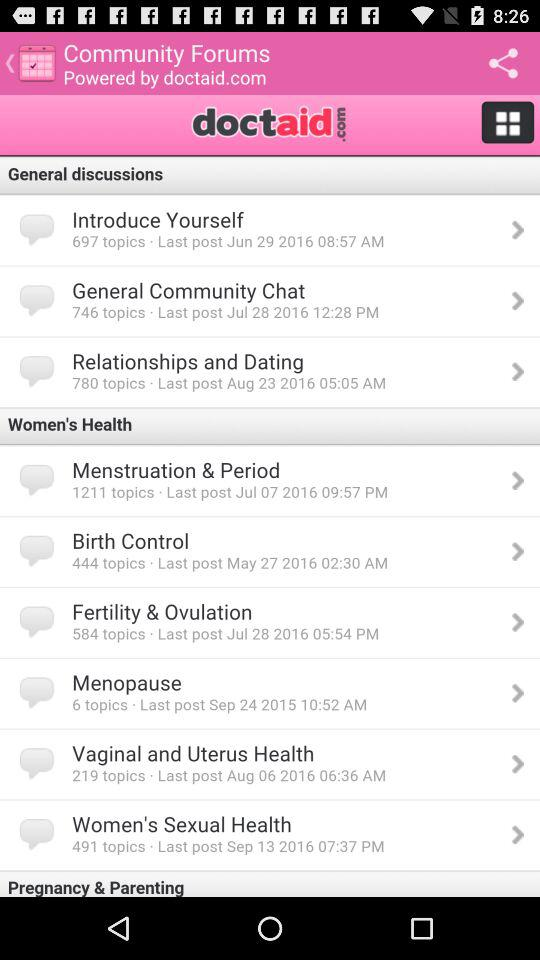How many topics are in the "General Community Chat"? There are 746 topics. 